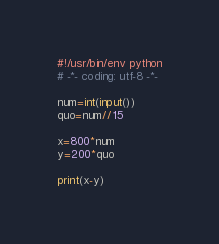<code> <loc_0><loc_0><loc_500><loc_500><_Python_>#!/usr/bin/env python
# -*- coding: utf-8 -*-

num=int(input())
quo=num//15

x=800*num
y=200*quo

print(x-y)
</code> 